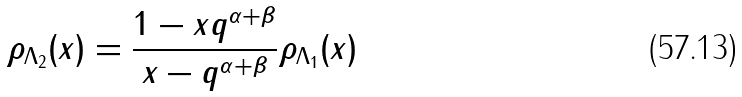Convert formula to latex. <formula><loc_0><loc_0><loc_500><loc_500>\rho _ { \Lambda _ { 2 } } ( x ) = \frac { 1 - x q ^ { \alpha + \beta } } { x - q ^ { \alpha + \beta } } \rho _ { \Lambda _ { 1 } } ( x )</formula> 